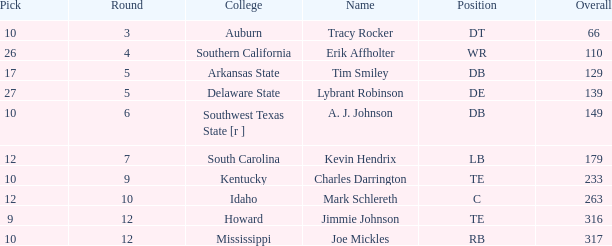What is the average Pick, when Name is "Lybrant Robinson", and when Overall is less than 139? None. 